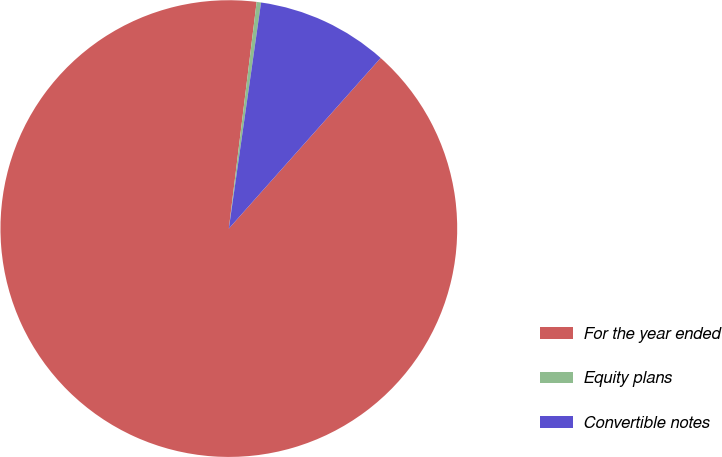<chart> <loc_0><loc_0><loc_500><loc_500><pie_chart><fcel>For the year ended<fcel>Equity plans<fcel>Convertible notes<nl><fcel>90.37%<fcel>0.31%<fcel>9.32%<nl></chart> 